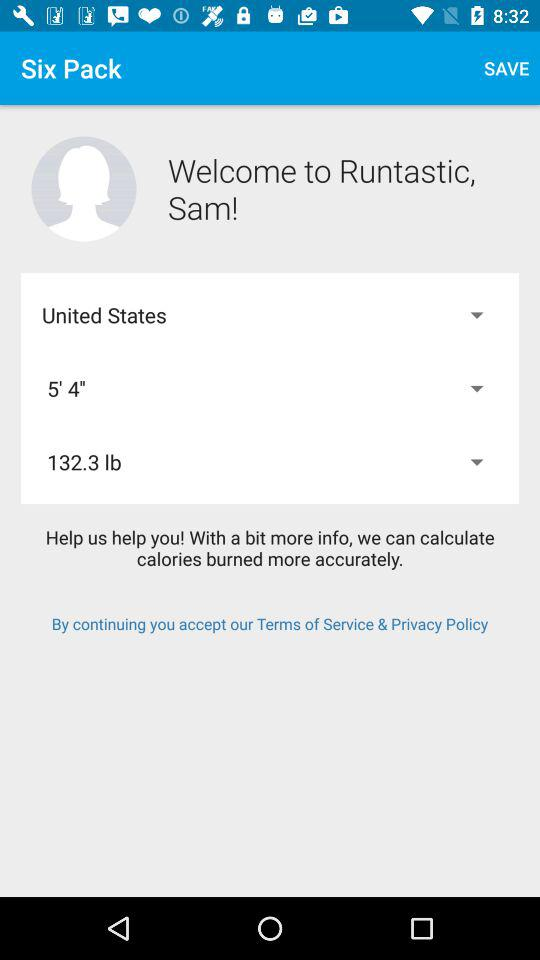Which measurement unit is used for weight? The used measurement unit is lb. 